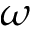<formula> <loc_0><loc_0><loc_500><loc_500>\omega</formula> 